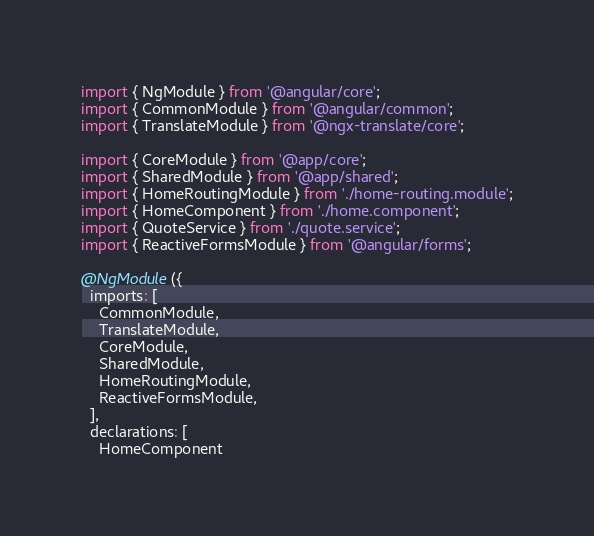<code> <loc_0><loc_0><loc_500><loc_500><_TypeScript_>import { NgModule } from '@angular/core';
import { CommonModule } from '@angular/common';
import { TranslateModule } from '@ngx-translate/core';

import { CoreModule } from '@app/core';
import { SharedModule } from '@app/shared';
import { HomeRoutingModule } from './home-routing.module';
import { HomeComponent } from './home.component';
import { QuoteService } from './quote.service';
import { ReactiveFormsModule } from '@angular/forms';

@NgModule({
  imports: [
    CommonModule,
    TranslateModule,
    CoreModule,
    SharedModule,
    HomeRoutingModule,
    ReactiveFormsModule,
  ],
  declarations: [
    HomeComponent</code> 